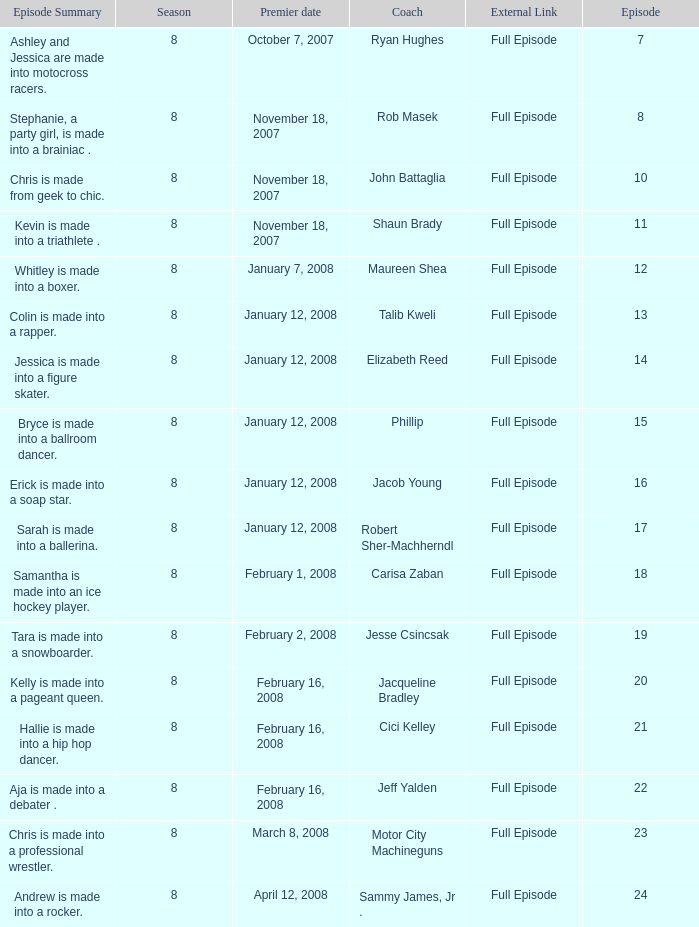Who was the coach for episode 15? Phillip. 